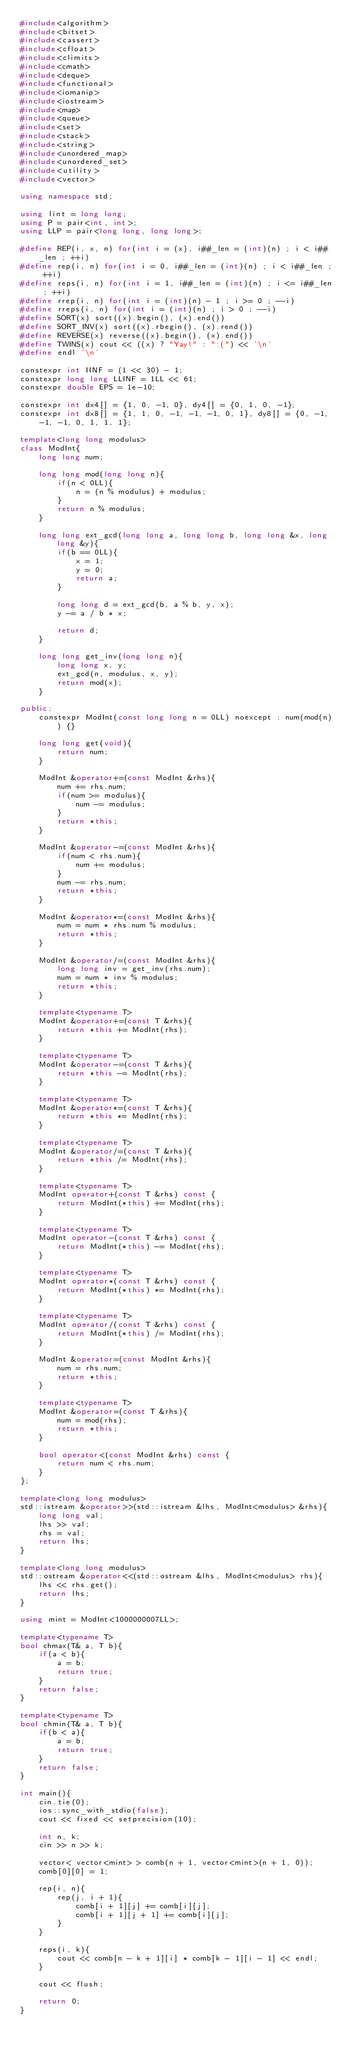<code> <loc_0><loc_0><loc_500><loc_500><_C++_>#include<algorithm>
#include<bitset>
#include<cassert>
#include<cfloat>
#include<climits>
#include<cmath>
#include<deque>
#include<functional>
#include<iomanip>
#include<iostream>
#include<map>
#include<queue>
#include<set>
#include<stack>
#include<string>
#include<unordered_map>
#include<unordered_set>
#include<utility>
#include<vector>

using namespace std;

using lint = long long;
using P = pair<int, int>;
using LLP = pair<long long, long long>;

#define REP(i, x, n) for(int i = (x), i##_len = (int)(n) ; i < i##_len ; ++i)
#define rep(i, n) for(int i = 0, i##_len = (int)(n) ; i < i##_len ; ++i)
#define reps(i, n) for(int i = 1, i##_len = (int)(n) ; i <= i##_len ; ++i)
#define rrep(i, n) for(int i = (int)(n) - 1 ; i >= 0 ; --i)
#define rreps(i, n) for(int i = (int)(n) ; i > 0 ; --i)
#define SORT(x) sort((x).begin(), (x).end())
#define SORT_INV(x) sort((x).rbegin(), (x).rend())
#define REVERSE(x) reverse((x).begin(), (x).end())
#define TWINS(x) cout << ((x) ? "Yay!" : ":(") << '\n'
#define endl '\n'

constexpr int IINF = (1 << 30) - 1;
constexpr long long LLINF = 1LL << 61;
constexpr double EPS = 1e-10;

constexpr int dx4[] = {1, 0, -1, 0}, dy4[] = {0, 1, 0, -1};
constexpr int dx8[] = {1, 1, 0, -1, -1, -1, 0, 1}, dy8[] = {0, -1, -1, -1, 0, 1, 1, 1};

template<long long modulus>
class ModInt{
    long long num;

    long long mod(long long n){
        if(n < 0LL){
            n = (n % modulus) + modulus;
        }
        return n % modulus;
    }

    long long ext_gcd(long long a, long long b, long long &x, long long &y){
        if(b == 0LL){
            x = 1;
            y = 0;
            return a;
        }

        long long d = ext_gcd(b, a % b, y, x);
        y -= a / b * x;

        return d;
    }

    long long get_inv(long long n){
        long long x, y;
        ext_gcd(n, modulus, x, y);
        return mod(x);
    }

public:
    constexpr ModInt(const long long n = 0LL) noexcept : num(mod(n)) {}

    long long get(void){
        return num;
    }

    ModInt &operator+=(const ModInt &rhs){
        num += rhs.num;
        if(num >= modulus){
            num -= modulus;
        }
        return *this;
    }

    ModInt &operator-=(const ModInt &rhs){
        if(num < rhs.num){
            num += modulus;
        }
        num -= rhs.num;
        return *this;
    }

    ModInt &operator*=(const ModInt &rhs){
        num = num * rhs.num % modulus;
        return *this;
    }

    ModInt &operator/=(const ModInt &rhs){
        long long inv = get_inv(rhs.num);
        num = num * inv % modulus;
        return *this;
    }

    template<typename T>
    ModInt &operator+=(const T &rhs){
        return *this += ModInt(rhs);
    }

    template<typename T>
    ModInt &operator-=(const T &rhs){
        return *this -= ModInt(rhs);
    }

    template<typename T>
    ModInt &operator*=(const T &rhs){
        return *this *= ModInt(rhs);
    }

    template<typename T>
    ModInt &operator/=(const T &rhs){
        return *this /= ModInt(rhs);
    }

    template<typename T>
    ModInt operator+(const T &rhs) const {
        return ModInt(*this) += ModInt(rhs);
    }

    template<typename T>
    ModInt operator-(const T &rhs) const {
        return ModInt(*this) -= ModInt(rhs);
    }

    template<typename T>
    ModInt operator*(const T &rhs) const {
        return ModInt(*this) *= ModInt(rhs);
    }

    template<typename T>
    ModInt operator/(const T &rhs) const {
        return ModInt(*this) /= ModInt(rhs);
    }

    ModInt &operator=(const ModInt &rhs){
        num = rhs.num;
        return *this;
    }

    template<typename T>
    ModInt &operator=(const T &rhs){
        num = mod(rhs);
        return *this;
    }

    bool operator<(const ModInt &rhs) const {
        return num < rhs.num;
    }
};

template<long long modulus>
std::istream &operator>>(std::istream &lhs, ModInt<modulus> &rhs){
    long long val;
    lhs >> val;
    rhs = val;
    return lhs;
}

template<long long modulus>
std::ostream &operator<<(std::ostream &lhs, ModInt<modulus> rhs){
    lhs << rhs.get();
    return lhs;
}

using mint = ModInt<1000000007LL>;

template<typename T>
bool chmax(T& a, T b){
    if(a < b){
        a = b;
        return true;
    }
    return false;
}

template<typename T>
bool chmin(T& a, T b){
    if(b < a){
        a = b;
        return true;
    }
    return false;
}

int main(){
    cin.tie(0);
    ios::sync_with_stdio(false);
    cout << fixed << setprecision(10);

    int n, k;
    cin >> n >> k;

    vector< vector<mint> > comb(n + 1, vector<mint>(n + 1, 0));
    comb[0][0] = 1;

    rep(i, n){
        rep(j, i + 1){
            comb[i + 1][j] += comb[i][j];
            comb[i + 1][j + 1] += comb[i][j];
        }
    }

    reps(i, k){
        cout << comb[n - k + 1][i] * comb[k - 1][i - 1] << endl;
    }

    cout << flush;

    return 0;
}</code> 